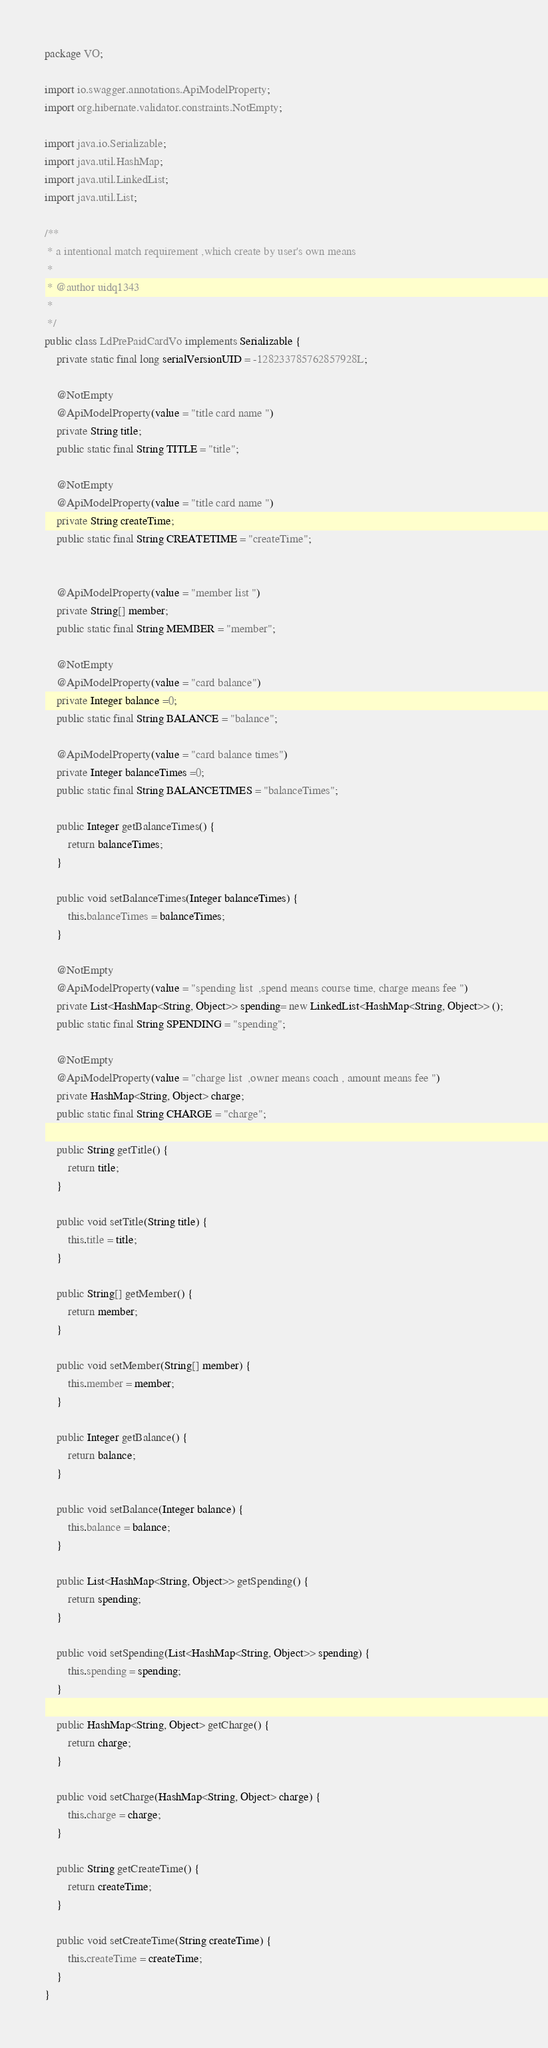Convert code to text. <code><loc_0><loc_0><loc_500><loc_500><_Java_>package VO;

import io.swagger.annotations.ApiModelProperty;
import org.hibernate.validator.constraints.NotEmpty;

import java.io.Serializable;
import java.util.HashMap;
import java.util.LinkedList;
import java.util.List;

/**
 * a intentional match requirement ,which create by user's own means
 * 
 * @author uidq1343
 *
 */
public class LdPrePaidCardVo implements Serializable {
    private static final long serialVersionUID = -128233785762857928L;

    @NotEmpty
    @ApiModelProperty(value = "title card name ")
    private String title;
    public static final String TITLE = "title";

    @NotEmpty
    @ApiModelProperty(value = "title card name ")
    private String createTime;
    public static final String CREATETIME = "createTime";


    @ApiModelProperty(value = "member list ")
    private String[] member;
    public static final String MEMBER = "member";

    @NotEmpty
    @ApiModelProperty(value = "card balance")
    private Integer balance =0;
    public static final String BALANCE = "balance";

    @ApiModelProperty(value = "card balance times")
    private Integer balanceTimes =0;
    public static final String BALANCETIMES = "balanceTimes";

    public Integer getBalanceTimes() {
        return balanceTimes;
    }

    public void setBalanceTimes(Integer balanceTimes) {
        this.balanceTimes = balanceTimes;
    }

    @NotEmpty
    @ApiModelProperty(value = "spending list  ,spend means course time, charge means fee ")
    private List<HashMap<String, Object>> spending= new LinkedList<HashMap<String, Object>> ();
    public static final String SPENDING = "spending";

    @NotEmpty
    @ApiModelProperty(value = "charge list  ,owner means coach , amount means fee ")
    private HashMap<String, Object> charge;
    public static final String CHARGE = "charge";

    public String getTitle() {
        return title;
    }

    public void setTitle(String title) {
        this.title = title;
    }

    public String[] getMember() {
        return member;
    }

    public void setMember(String[] member) {
        this.member = member;
    }

    public Integer getBalance() {
        return balance;
    }

    public void setBalance(Integer balance) {
        this.balance = balance;
    }

    public List<HashMap<String, Object>> getSpending() {
        return spending;
    }

    public void setSpending(List<HashMap<String, Object>> spending) {
        this.spending = spending;
    }

    public HashMap<String, Object> getCharge() {
        return charge;
    }

    public void setCharge(HashMap<String, Object> charge) {
        this.charge = charge;
    }

    public String getCreateTime() {
        return createTime;
    }

    public void setCreateTime(String createTime) {
        this.createTime = createTime;
    }
}
</code> 